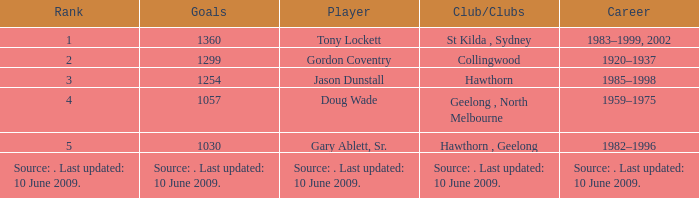Which player has 1299 goals? Gordon Coventry. 